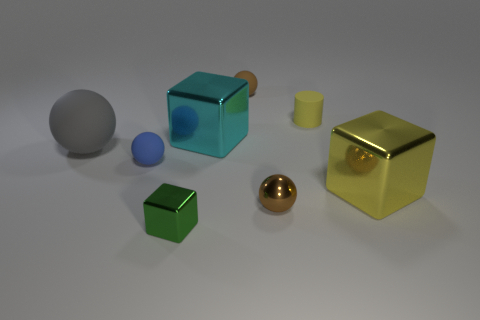Add 1 small gray matte cubes. How many objects exist? 9 Subtract all cylinders. How many objects are left? 7 Subtract all blue matte balls. Subtract all green things. How many objects are left? 6 Add 4 tiny metallic objects. How many tiny metallic objects are left? 6 Add 1 tiny cyan things. How many tiny cyan things exist? 1 Subtract 1 blue spheres. How many objects are left? 7 